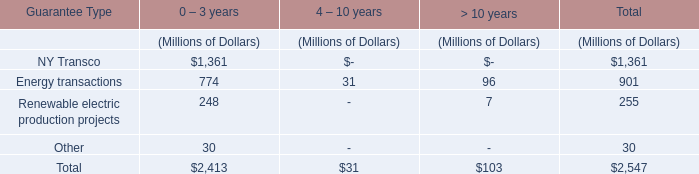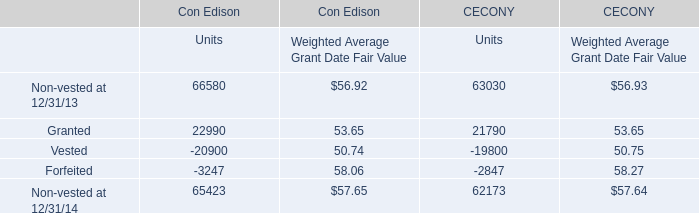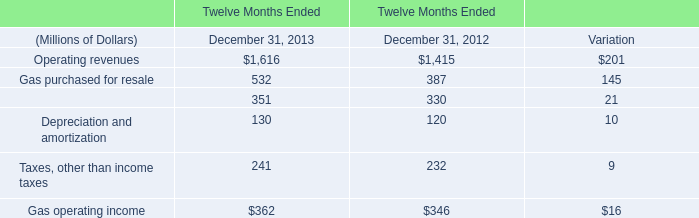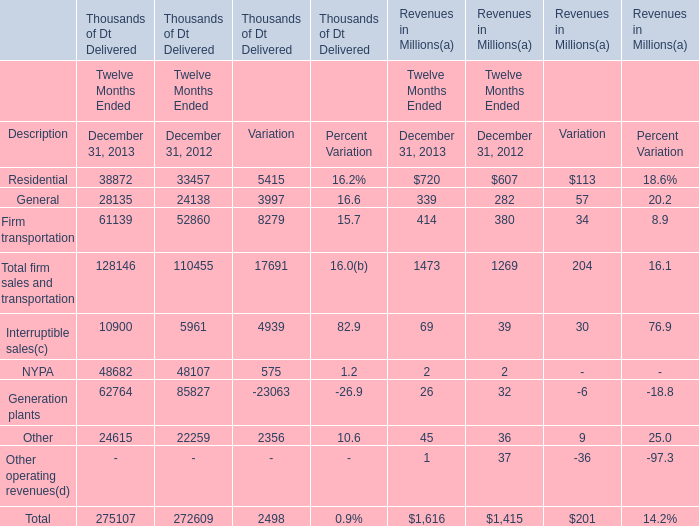What is the sum of Residential, General and Firm transportation in 2013 for Revenues? (in Million) 
Computations: ((720 + 339) + 414)
Answer: 1473.0. 